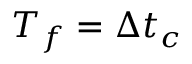Convert formula to latex. <formula><loc_0><loc_0><loc_500><loc_500>T _ { f } = \Delta t _ { c }</formula> 